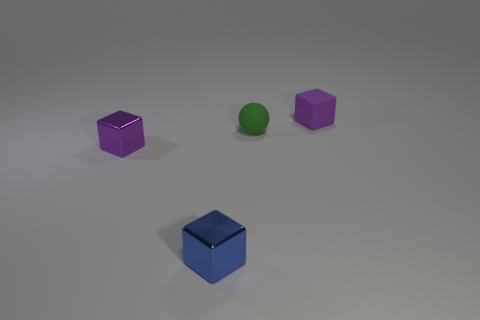Are there any other objects that have the same shape as the small blue thing?
Keep it short and to the point. Yes. Do the small block to the left of the tiny blue metallic cube and the rubber block have the same color?
Your answer should be very brief. Yes. What material is the small block in front of the small purple object on the left side of the tiny blue metallic object?
Provide a succinct answer. Metal. What is the color of the ball?
Make the answer very short. Green. There is a purple thing on the left side of the blue object; is there a metallic cube that is in front of it?
Keep it short and to the point. Yes. What is the material of the ball?
Provide a succinct answer. Rubber. Is the purple block that is in front of the purple matte block made of the same material as the tiny green object right of the blue thing?
Keep it short and to the point. No. Is there anything else of the same color as the matte ball?
Make the answer very short. No. There is a tiny matte thing that is the same shape as the tiny blue metallic object; what is its color?
Keep it short and to the point. Purple. There is a thing that is both in front of the tiny matte cube and on the right side of the small blue metallic thing; what size is it?
Your response must be concise. Small. 